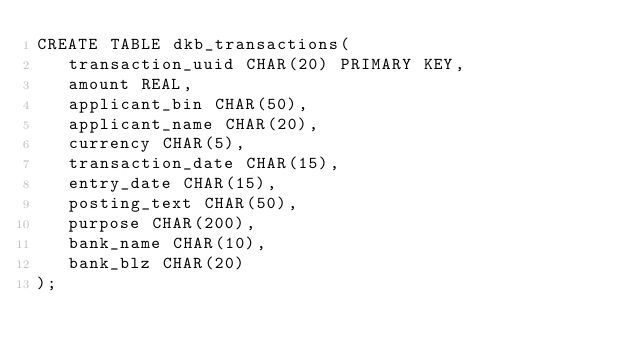Convert code to text. <code><loc_0><loc_0><loc_500><loc_500><_SQL_>CREATE TABLE dkb_transactions(
   transaction_uuid CHAR(20) PRIMARY KEY,
   amount REAL,
   applicant_bin CHAR(50),
   applicant_name CHAR(20),
   currency CHAR(5),
   transaction_date CHAR(15),
   entry_date CHAR(15),
   posting_text CHAR(50),
   purpose CHAR(200),
   bank_name CHAR(10),
   bank_blz CHAR(20)
);</code> 